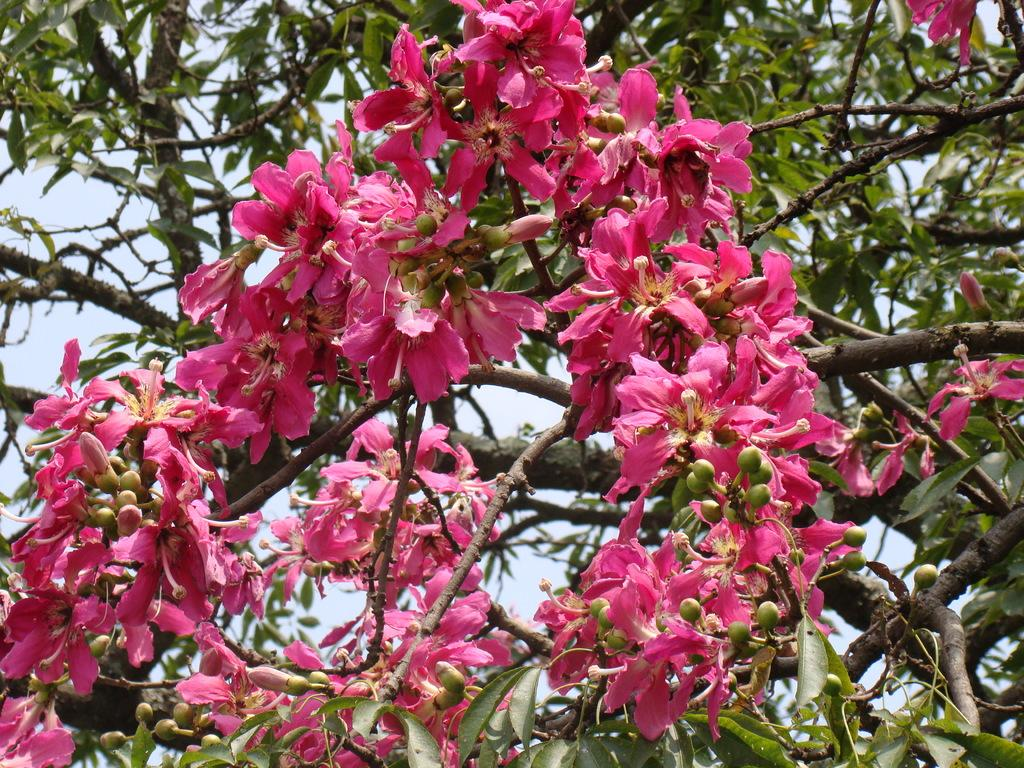What is the main subject of the image? The main subject of the image is a tree. What can be observed about the tree in the image? The tree has many pink flowers. What can be seen in the background of the image? The sky is visible in the background of the image. Where is the baby sitting in the image? There is no baby present in the image; it features a tree with pink flowers and a visible sky in the background. 